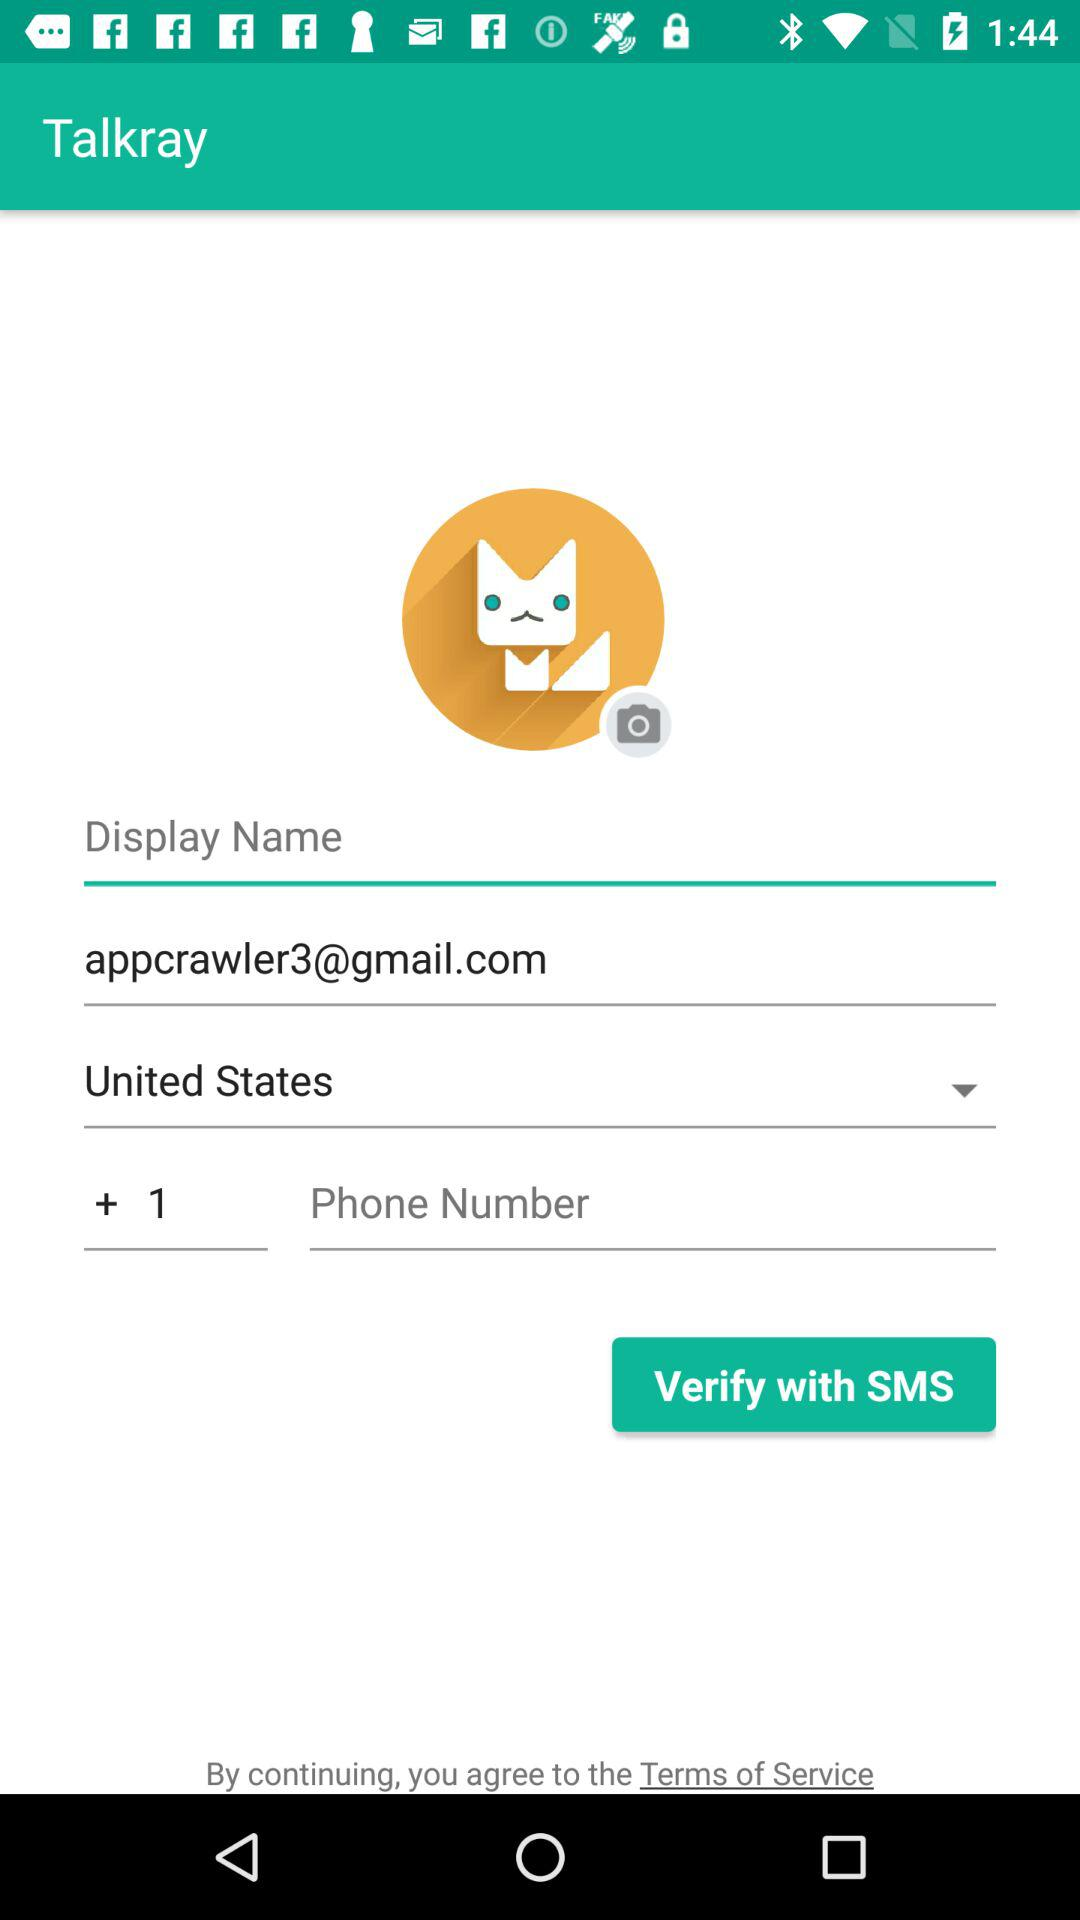What's the country code? The country code is +1. 